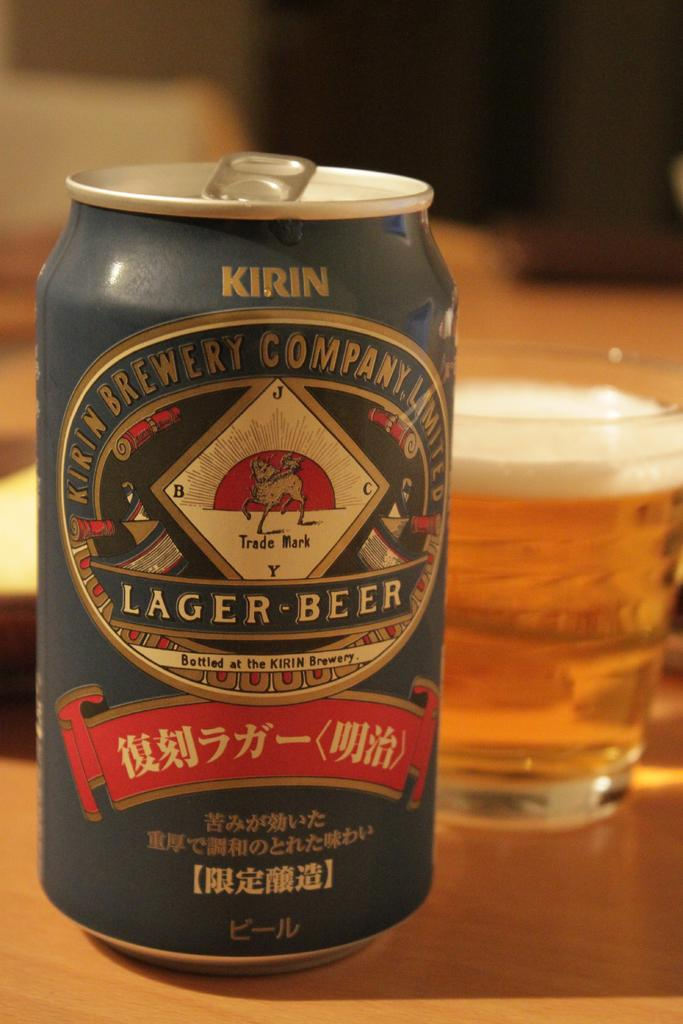<image>
Write a terse but informative summary of the picture. Can of Kirin Lager-Beer from the Kirin Brewery Company Limited. 